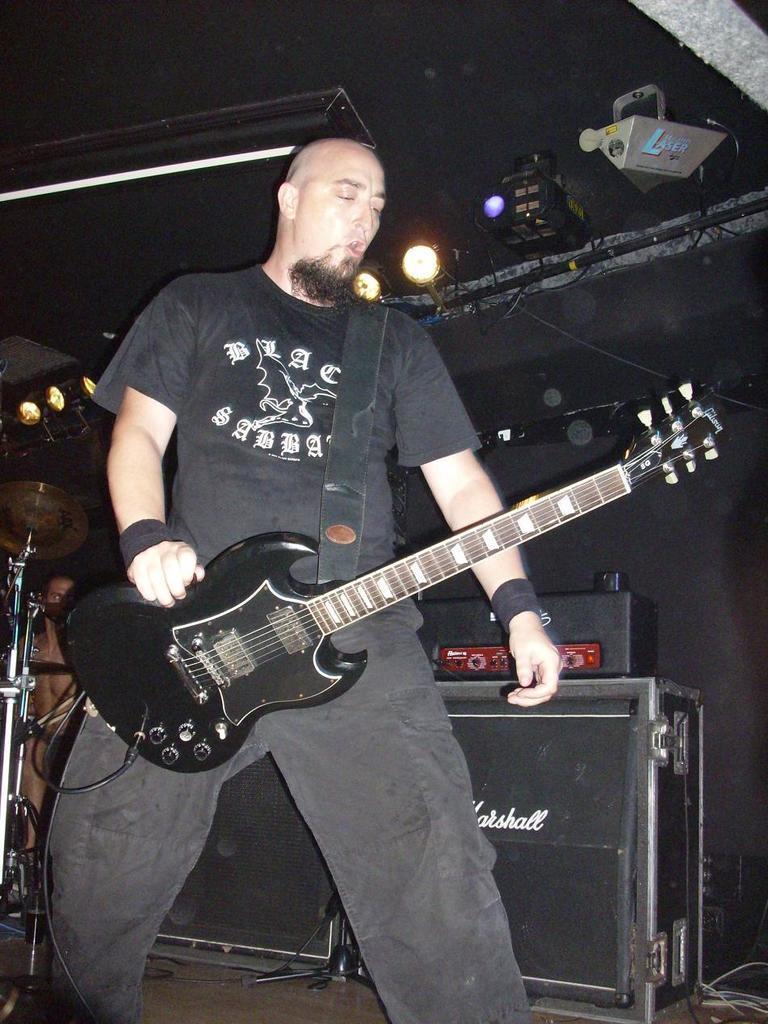Please provide a concise description of this image. Here is a person standing and holding guitar. I think he is singing the song. At background I can see speakers and some other object which are black in color. These look like show lights. This is a hi-hat instrument. 